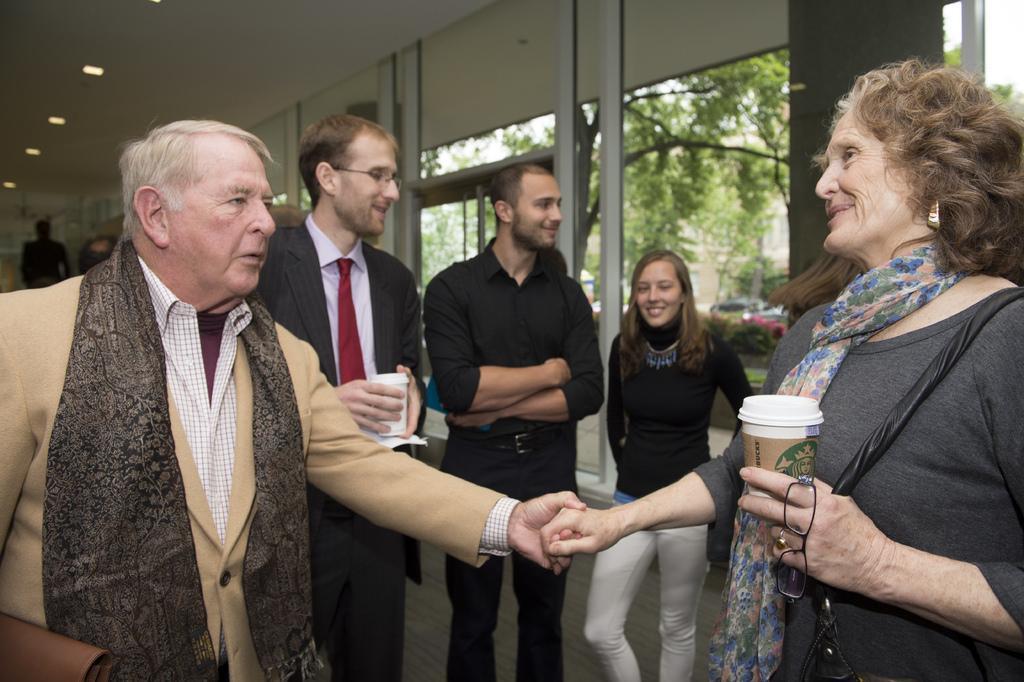How would you summarize this image in a sentence or two? In the image we can see there are many people standing and wearing clothes. On the right side, we can see a woman wearing earrings, carrying bag and she is holding glass and spectacles in her hand. Here we can see the floor, lights and glass windows, out of the window we can see the vehicles and the trees. 